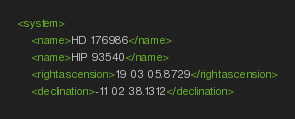<code> <loc_0><loc_0><loc_500><loc_500><_XML_><system>
	<name>HD 176986</name>
	<name>HIP 93540</name>
	<rightascension>19 03 05.8729</rightascension>
	<declination>-11 02 38.1312</declination></code> 